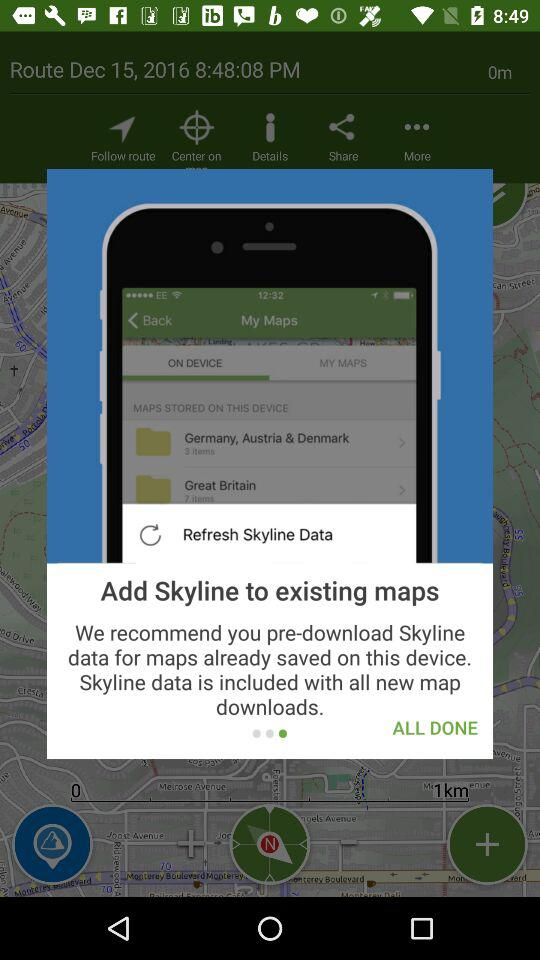Which date shows up on the screen? The date is December 15, 2016. 